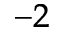<formula> <loc_0><loc_0><loc_500><loc_500>^ { - 2 }</formula> 